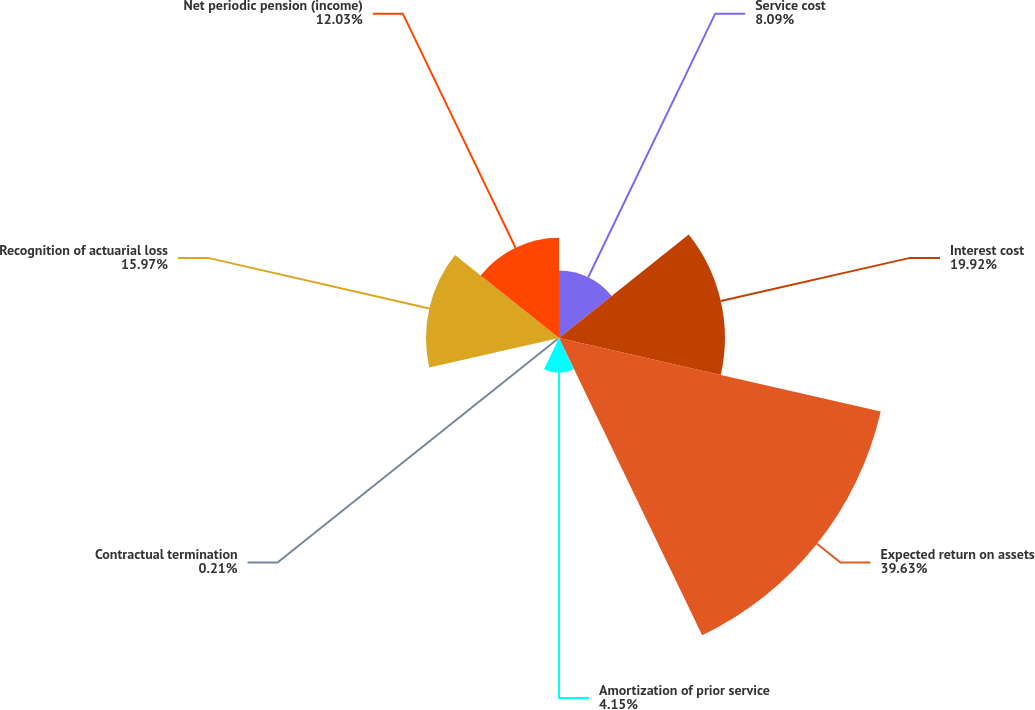<chart> <loc_0><loc_0><loc_500><loc_500><pie_chart><fcel>Service cost<fcel>Interest cost<fcel>Expected return on assets<fcel>Amortization of prior service<fcel>Contractual termination<fcel>Recognition of actuarial loss<fcel>Net periodic pension (income)<nl><fcel>8.09%<fcel>19.92%<fcel>39.62%<fcel>4.15%<fcel>0.21%<fcel>15.97%<fcel>12.03%<nl></chart> 